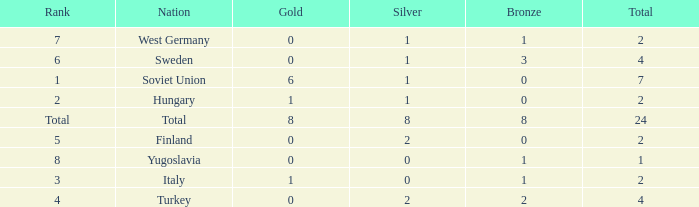What is the sum of Total, when Silver is 0, and when Gold is 1? 2.0. 